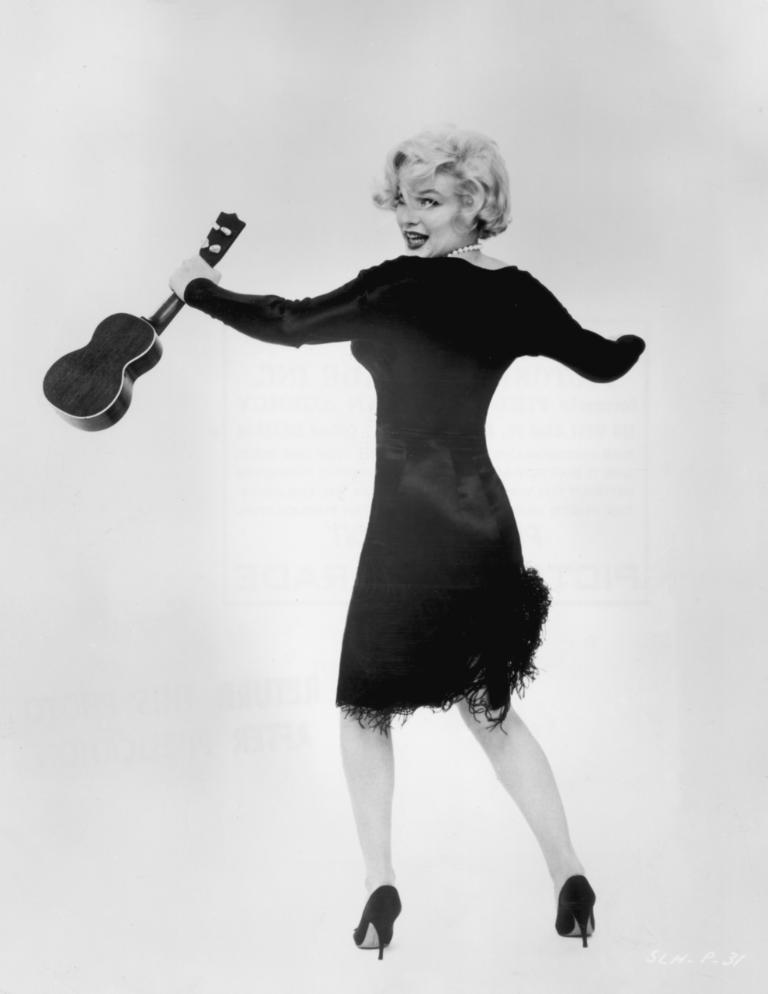Who is the main subject in the image? There is a woman in the image. What is the woman wearing? The woman is wearing a black dress. What is the woman holding in her hand? The woman is holding a black color guitar in her hand. What is the answer to the riddle that the woman is holding in her hand? There is no riddle present in the image, as the woman is holding a guitar, not a riddle. 